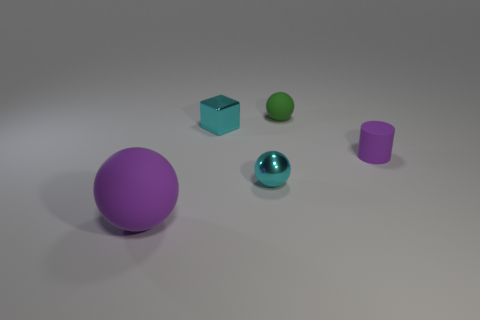How many matte objects are either purple spheres or tiny cylinders?
Provide a short and direct response. 2. What is the color of the other tiny object that is the same shape as the green rubber thing?
Make the answer very short. Cyan. Is there a big green cylinder?
Give a very brief answer. No. Is the sphere that is behind the purple matte cylinder made of the same material as the purple thing that is on the right side of the small shiny ball?
Your response must be concise. Yes. There is a small thing that is the same color as the large object; what shape is it?
Make the answer very short. Cylinder. How many objects are either small cyan objects that are in front of the cyan metallic cube or tiny objects that are behind the tiny cyan shiny sphere?
Your answer should be very brief. 4. There is a ball right of the small shiny ball; is it the same color as the tiny metallic thing that is behind the cyan metal ball?
Your response must be concise. No. The object that is to the right of the cyan metal block and behind the tiny purple cylinder has what shape?
Give a very brief answer. Sphere. There is a shiny block that is the same size as the green thing; what is its color?
Ensure brevity in your answer.  Cyan. Are there any tiny things that have the same color as the small matte cylinder?
Your response must be concise. No. 